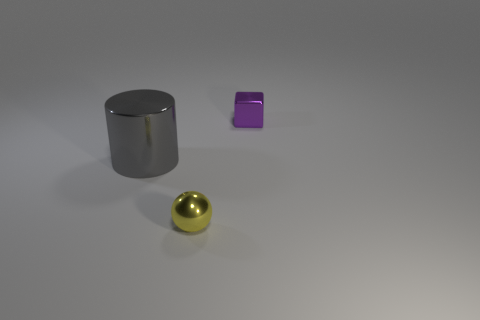Is there anything else that is the same size as the ball?
Make the answer very short. Yes. Are there fewer tiny yellow spheres on the left side of the large gray cylinder than tiny shiny blocks to the left of the yellow thing?
Your response must be concise. No. What number of tiny metal objects are the same color as the tiny cube?
Your answer should be very brief. 0. How many things are on the left side of the tiny purple cube and to the right of the metallic ball?
Keep it short and to the point. 0. What material is the thing left of the tiny thing in front of the purple metallic object?
Ensure brevity in your answer.  Metal. Is there another tiny purple cylinder that has the same material as the cylinder?
Give a very brief answer. No. What material is the other thing that is the same size as the purple thing?
Make the answer very short. Metal. There is a thing right of the small shiny thing that is in front of the small object that is behind the gray thing; what size is it?
Make the answer very short. Small. Are there any gray metal things that are in front of the small metallic object behind the gray metal object?
Offer a very short reply. Yes. There is a large gray thing; is it the same shape as the tiny thing that is on the left side of the small shiny cube?
Ensure brevity in your answer.  No. 